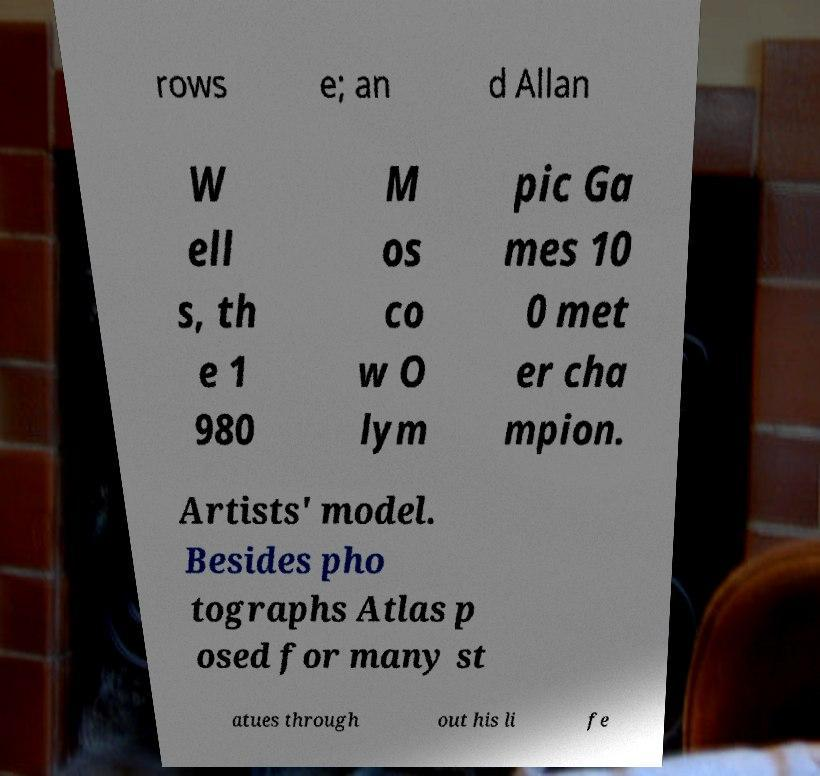Could you assist in decoding the text presented in this image and type it out clearly? rows e; an d Allan W ell s, th e 1 980 M os co w O lym pic Ga mes 10 0 met er cha mpion. Artists' model. Besides pho tographs Atlas p osed for many st atues through out his li fe 